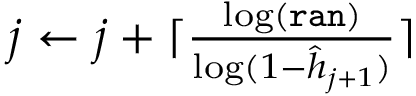Convert formula to latex. <formula><loc_0><loc_0><loc_500><loc_500>\begin{array} { r } { j \gets j + \lceil \frac { \log \left ( \tt { r a n } \right ) } { \log ( 1 - \hat { h } _ { j + 1 } ) } \rceil } \end{array}</formula> 